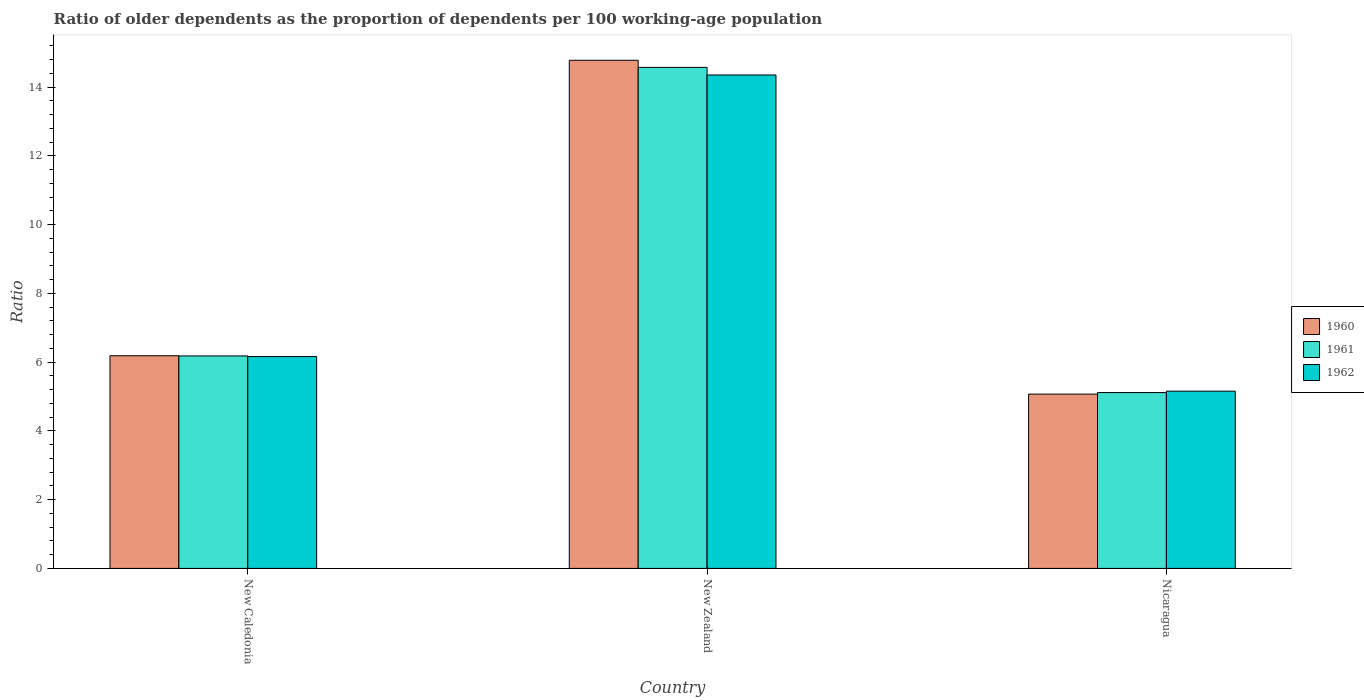How many groups of bars are there?
Give a very brief answer. 3. Are the number of bars per tick equal to the number of legend labels?
Give a very brief answer. Yes. How many bars are there on the 2nd tick from the left?
Provide a succinct answer. 3. How many bars are there on the 2nd tick from the right?
Provide a short and direct response. 3. What is the label of the 2nd group of bars from the left?
Your answer should be very brief. New Zealand. In how many cases, is the number of bars for a given country not equal to the number of legend labels?
Provide a short and direct response. 0. What is the age dependency ratio(old) in 1961 in Nicaragua?
Keep it short and to the point. 5.11. Across all countries, what is the maximum age dependency ratio(old) in 1962?
Your answer should be very brief. 14.35. Across all countries, what is the minimum age dependency ratio(old) in 1960?
Ensure brevity in your answer.  5.07. In which country was the age dependency ratio(old) in 1962 maximum?
Make the answer very short. New Zealand. In which country was the age dependency ratio(old) in 1962 minimum?
Ensure brevity in your answer.  Nicaragua. What is the total age dependency ratio(old) in 1960 in the graph?
Make the answer very short. 26.04. What is the difference between the age dependency ratio(old) in 1961 in New Caledonia and that in Nicaragua?
Keep it short and to the point. 1.07. What is the difference between the age dependency ratio(old) in 1961 in Nicaragua and the age dependency ratio(old) in 1960 in New Zealand?
Provide a succinct answer. -9.67. What is the average age dependency ratio(old) in 1960 per country?
Give a very brief answer. 8.68. What is the difference between the age dependency ratio(old) of/in 1961 and age dependency ratio(old) of/in 1960 in Nicaragua?
Keep it short and to the point. 0.04. What is the ratio of the age dependency ratio(old) in 1960 in New Caledonia to that in New Zealand?
Offer a terse response. 0.42. Is the age dependency ratio(old) in 1962 in New Caledonia less than that in New Zealand?
Give a very brief answer. Yes. Is the difference between the age dependency ratio(old) in 1961 in New Caledonia and Nicaragua greater than the difference between the age dependency ratio(old) in 1960 in New Caledonia and Nicaragua?
Make the answer very short. No. What is the difference between the highest and the second highest age dependency ratio(old) in 1960?
Your response must be concise. -9.71. What is the difference between the highest and the lowest age dependency ratio(old) in 1961?
Your answer should be compact. 9.46. In how many countries, is the age dependency ratio(old) in 1960 greater than the average age dependency ratio(old) in 1960 taken over all countries?
Your answer should be compact. 1. Is it the case that in every country, the sum of the age dependency ratio(old) in 1962 and age dependency ratio(old) in 1960 is greater than the age dependency ratio(old) in 1961?
Keep it short and to the point. Yes. How many bars are there?
Your answer should be compact. 9. Are all the bars in the graph horizontal?
Provide a short and direct response. No. How many countries are there in the graph?
Your answer should be compact. 3. What is the difference between two consecutive major ticks on the Y-axis?
Provide a succinct answer. 2. Does the graph contain grids?
Make the answer very short. No. How many legend labels are there?
Make the answer very short. 3. How are the legend labels stacked?
Provide a short and direct response. Vertical. What is the title of the graph?
Make the answer very short. Ratio of older dependents as the proportion of dependents per 100 working-age population. What is the label or title of the X-axis?
Provide a succinct answer. Country. What is the label or title of the Y-axis?
Your answer should be very brief. Ratio. What is the Ratio of 1960 in New Caledonia?
Your response must be concise. 6.19. What is the Ratio in 1961 in New Caledonia?
Keep it short and to the point. 6.18. What is the Ratio in 1962 in New Caledonia?
Provide a short and direct response. 6.16. What is the Ratio of 1960 in New Zealand?
Offer a terse response. 14.78. What is the Ratio in 1961 in New Zealand?
Offer a terse response. 14.57. What is the Ratio in 1962 in New Zealand?
Ensure brevity in your answer.  14.35. What is the Ratio of 1960 in Nicaragua?
Ensure brevity in your answer.  5.07. What is the Ratio of 1961 in Nicaragua?
Give a very brief answer. 5.11. What is the Ratio in 1962 in Nicaragua?
Offer a terse response. 5.16. Across all countries, what is the maximum Ratio in 1960?
Your answer should be compact. 14.78. Across all countries, what is the maximum Ratio of 1961?
Your answer should be compact. 14.57. Across all countries, what is the maximum Ratio in 1962?
Offer a very short reply. 14.35. Across all countries, what is the minimum Ratio of 1960?
Provide a short and direct response. 5.07. Across all countries, what is the minimum Ratio of 1961?
Make the answer very short. 5.11. Across all countries, what is the minimum Ratio in 1962?
Offer a terse response. 5.16. What is the total Ratio of 1960 in the graph?
Provide a short and direct response. 26.04. What is the total Ratio of 1961 in the graph?
Provide a succinct answer. 25.87. What is the total Ratio in 1962 in the graph?
Provide a succinct answer. 25.67. What is the difference between the Ratio of 1960 in New Caledonia and that in New Zealand?
Offer a terse response. -8.59. What is the difference between the Ratio in 1961 in New Caledonia and that in New Zealand?
Offer a terse response. -8.39. What is the difference between the Ratio of 1962 in New Caledonia and that in New Zealand?
Your answer should be very brief. -8.19. What is the difference between the Ratio in 1960 in New Caledonia and that in Nicaragua?
Keep it short and to the point. 1.12. What is the difference between the Ratio in 1961 in New Caledonia and that in Nicaragua?
Offer a very short reply. 1.07. What is the difference between the Ratio of 1962 in New Caledonia and that in Nicaragua?
Make the answer very short. 1.01. What is the difference between the Ratio of 1960 in New Zealand and that in Nicaragua?
Offer a very short reply. 9.71. What is the difference between the Ratio of 1961 in New Zealand and that in Nicaragua?
Your answer should be very brief. 9.46. What is the difference between the Ratio of 1962 in New Zealand and that in Nicaragua?
Offer a very short reply. 9.2. What is the difference between the Ratio in 1960 in New Caledonia and the Ratio in 1961 in New Zealand?
Provide a short and direct response. -8.39. What is the difference between the Ratio of 1960 in New Caledonia and the Ratio of 1962 in New Zealand?
Make the answer very short. -8.17. What is the difference between the Ratio of 1961 in New Caledonia and the Ratio of 1962 in New Zealand?
Give a very brief answer. -8.17. What is the difference between the Ratio in 1960 in New Caledonia and the Ratio in 1961 in Nicaragua?
Offer a very short reply. 1.07. What is the difference between the Ratio in 1960 in New Caledonia and the Ratio in 1962 in Nicaragua?
Your response must be concise. 1.03. What is the difference between the Ratio of 1961 in New Caledonia and the Ratio of 1962 in Nicaragua?
Keep it short and to the point. 1.02. What is the difference between the Ratio of 1960 in New Zealand and the Ratio of 1961 in Nicaragua?
Make the answer very short. 9.67. What is the difference between the Ratio of 1960 in New Zealand and the Ratio of 1962 in Nicaragua?
Provide a short and direct response. 9.62. What is the difference between the Ratio in 1961 in New Zealand and the Ratio in 1962 in Nicaragua?
Ensure brevity in your answer.  9.42. What is the average Ratio in 1960 per country?
Keep it short and to the point. 8.68. What is the average Ratio of 1961 per country?
Give a very brief answer. 8.62. What is the average Ratio in 1962 per country?
Ensure brevity in your answer.  8.56. What is the difference between the Ratio of 1960 and Ratio of 1961 in New Caledonia?
Provide a succinct answer. 0.01. What is the difference between the Ratio in 1960 and Ratio in 1962 in New Caledonia?
Your answer should be very brief. 0.02. What is the difference between the Ratio of 1961 and Ratio of 1962 in New Caledonia?
Offer a very short reply. 0.02. What is the difference between the Ratio in 1960 and Ratio in 1961 in New Zealand?
Provide a succinct answer. 0.21. What is the difference between the Ratio in 1960 and Ratio in 1962 in New Zealand?
Your response must be concise. 0.43. What is the difference between the Ratio of 1961 and Ratio of 1962 in New Zealand?
Provide a short and direct response. 0.22. What is the difference between the Ratio in 1960 and Ratio in 1961 in Nicaragua?
Your response must be concise. -0.04. What is the difference between the Ratio of 1960 and Ratio of 1962 in Nicaragua?
Ensure brevity in your answer.  -0.09. What is the difference between the Ratio of 1961 and Ratio of 1962 in Nicaragua?
Provide a succinct answer. -0.04. What is the ratio of the Ratio in 1960 in New Caledonia to that in New Zealand?
Provide a succinct answer. 0.42. What is the ratio of the Ratio of 1961 in New Caledonia to that in New Zealand?
Give a very brief answer. 0.42. What is the ratio of the Ratio of 1962 in New Caledonia to that in New Zealand?
Make the answer very short. 0.43. What is the ratio of the Ratio in 1960 in New Caledonia to that in Nicaragua?
Provide a succinct answer. 1.22. What is the ratio of the Ratio of 1961 in New Caledonia to that in Nicaragua?
Ensure brevity in your answer.  1.21. What is the ratio of the Ratio in 1962 in New Caledonia to that in Nicaragua?
Provide a short and direct response. 1.2. What is the ratio of the Ratio of 1960 in New Zealand to that in Nicaragua?
Provide a succinct answer. 2.92. What is the ratio of the Ratio of 1961 in New Zealand to that in Nicaragua?
Your answer should be very brief. 2.85. What is the ratio of the Ratio in 1962 in New Zealand to that in Nicaragua?
Provide a short and direct response. 2.78. What is the difference between the highest and the second highest Ratio in 1960?
Keep it short and to the point. 8.59. What is the difference between the highest and the second highest Ratio in 1961?
Provide a succinct answer. 8.39. What is the difference between the highest and the second highest Ratio in 1962?
Give a very brief answer. 8.19. What is the difference between the highest and the lowest Ratio of 1960?
Provide a succinct answer. 9.71. What is the difference between the highest and the lowest Ratio in 1961?
Offer a very short reply. 9.46. What is the difference between the highest and the lowest Ratio in 1962?
Give a very brief answer. 9.2. 